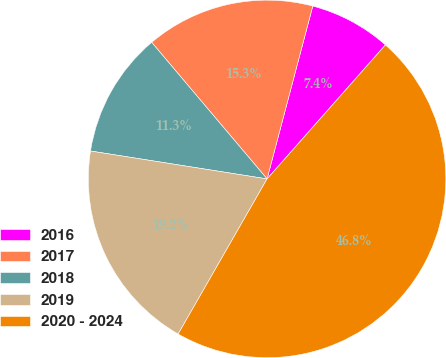<chart> <loc_0><loc_0><loc_500><loc_500><pie_chart><fcel>2016<fcel>2017<fcel>2018<fcel>2019<fcel>2020 - 2024<nl><fcel>7.4%<fcel>15.28%<fcel>11.34%<fcel>19.21%<fcel>46.77%<nl></chart> 